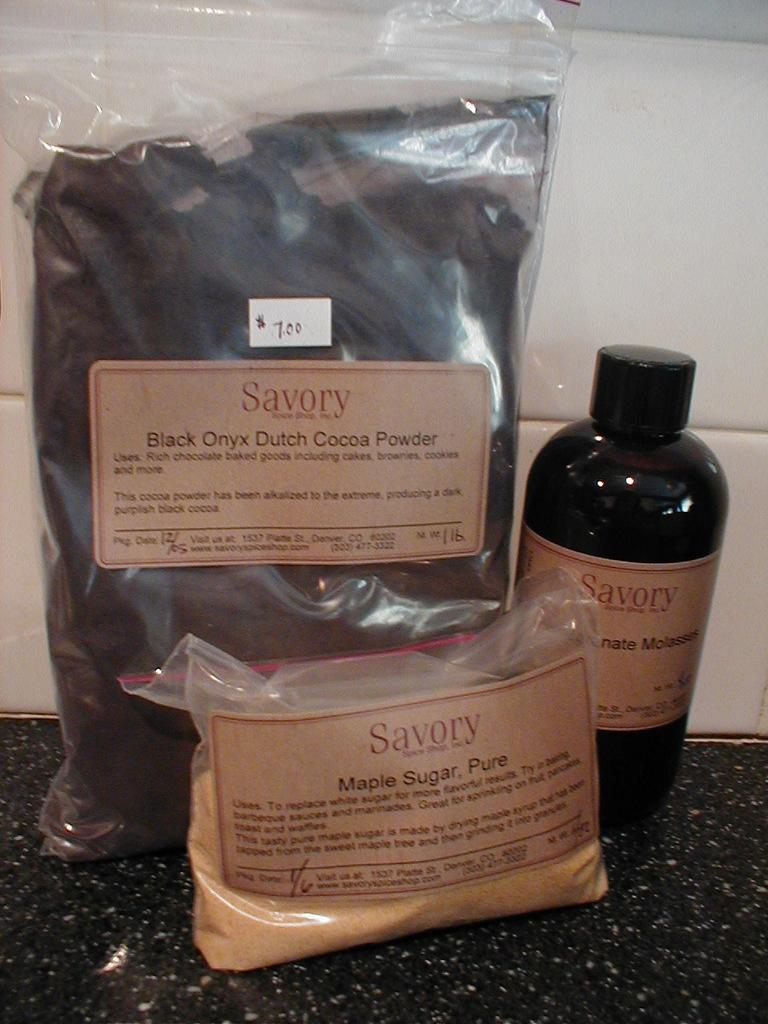<image>
Describe the image concisely. A bag of Savory Black Onynx Dutch Cocoa powder is on a counter with ingredients. 